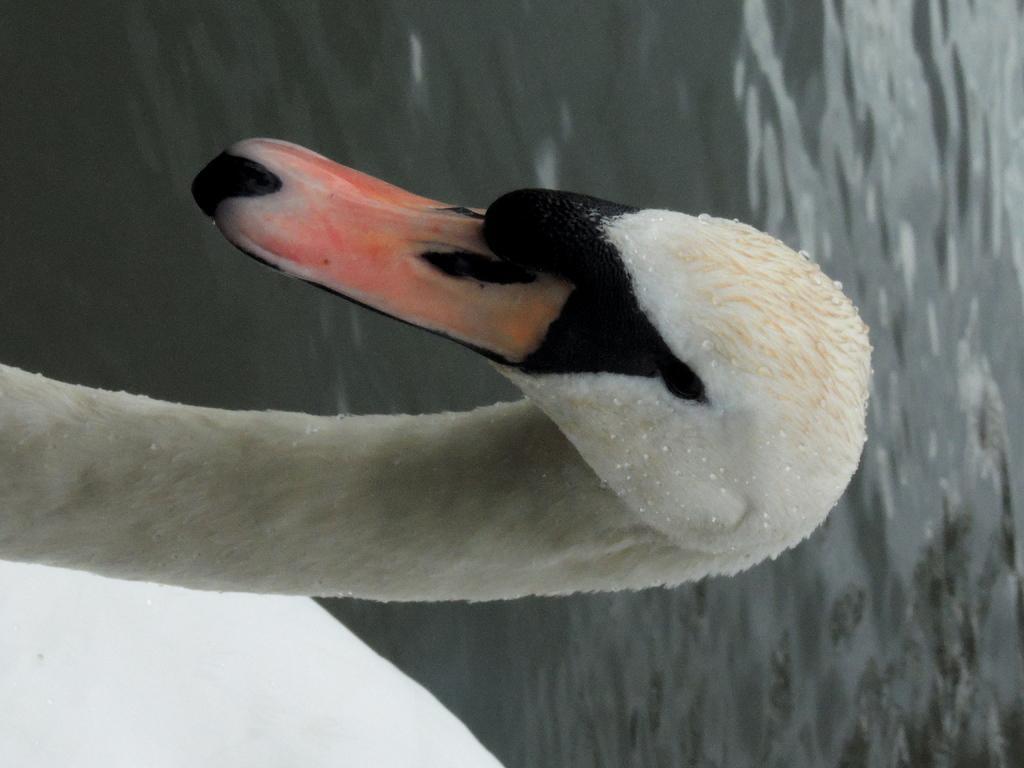In one or two sentences, can you explain what this image depicts? In this image I can see a bird in white, black and orange color and I can see the water. 